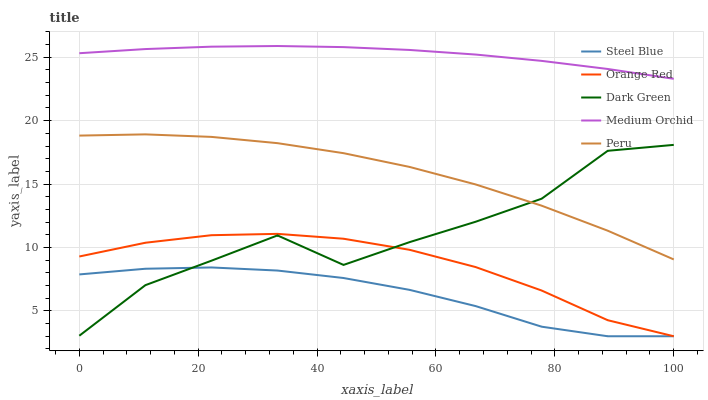Does Dark Green have the minimum area under the curve?
Answer yes or no. No. Does Dark Green have the maximum area under the curve?
Answer yes or no. No. Is Steel Blue the smoothest?
Answer yes or no. No. Is Steel Blue the roughest?
Answer yes or no. No. Does Dark Green have the lowest value?
Answer yes or no. No. Does Dark Green have the highest value?
Answer yes or no. No. Is Dark Green less than Medium Orchid?
Answer yes or no. Yes. Is Peru greater than Orange Red?
Answer yes or no. Yes. Does Dark Green intersect Medium Orchid?
Answer yes or no. No. 